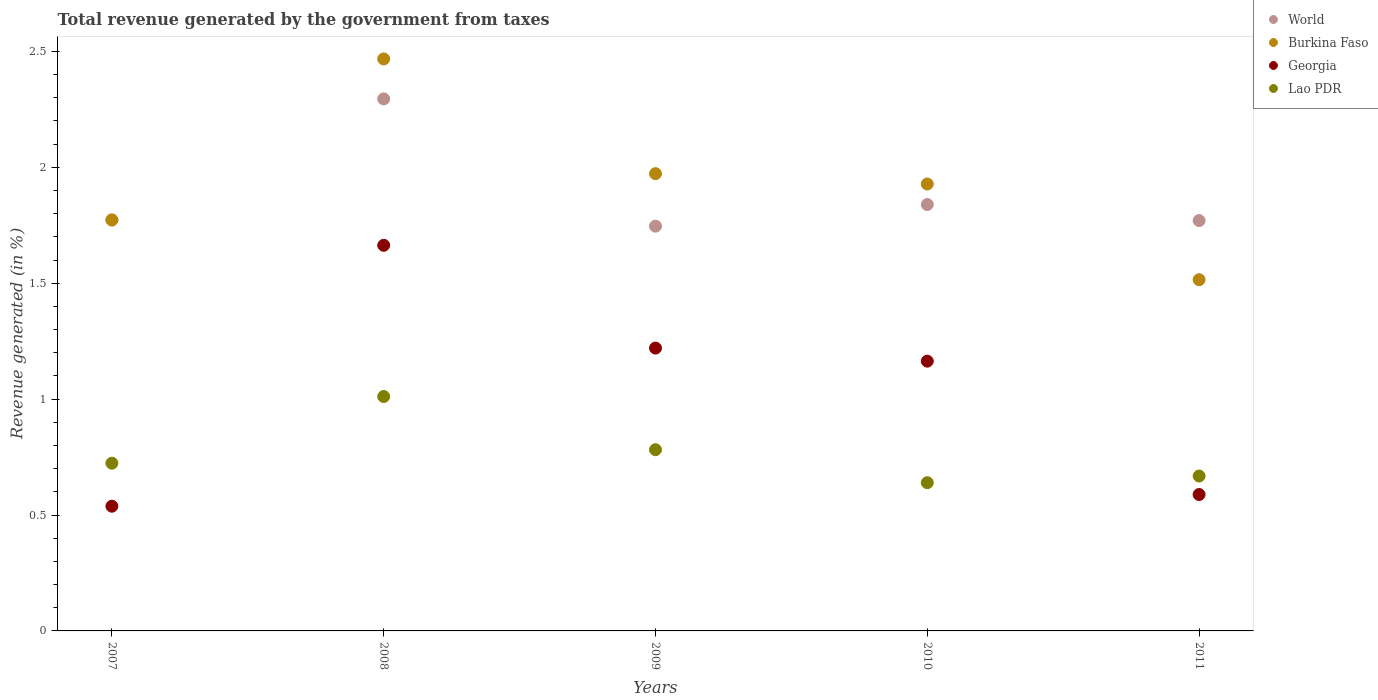How many different coloured dotlines are there?
Keep it short and to the point. 4. What is the total revenue generated in Burkina Faso in 2009?
Your answer should be very brief. 1.97. Across all years, what is the maximum total revenue generated in World?
Your answer should be very brief. 2.3. Across all years, what is the minimum total revenue generated in World?
Provide a short and direct response. 1.75. In which year was the total revenue generated in Lao PDR maximum?
Provide a succinct answer. 2008. What is the total total revenue generated in World in the graph?
Provide a succinct answer. 9.42. What is the difference between the total revenue generated in Georgia in 2008 and that in 2009?
Provide a succinct answer. 0.44. What is the difference between the total revenue generated in World in 2007 and the total revenue generated in Lao PDR in 2010?
Ensure brevity in your answer.  1.13. What is the average total revenue generated in Georgia per year?
Offer a terse response. 1.03. In the year 2011, what is the difference between the total revenue generated in World and total revenue generated in Georgia?
Your response must be concise. 1.18. What is the ratio of the total revenue generated in Burkina Faso in 2007 to that in 2010?
Ensure brevity in your answer.  0.92. Is the difference between the total revenue generated in World in 2009 and 2011 greater than the difference between the total revenue generated in Georgia in 2009 and 2011?
Offer a very short reply. No. What is the difference between the highest and the second highest total revenue generated in World?
Give a very brief answer. 0.46. What is the difference between the highest and the lowest total revenue generated in Georgia?
Make the answer very short. 1.13. Is the sum of the total revenue generated in Lao PDR in 2010 and 2011 greater than the maximum total revenue generated in World across all years?
Ensure brevity in your answer.  No. How many dotlines are there?
Provide a succinct answer. 4. How many years are there in the graph?
Ensure brevity in your answer.  5. Are the values on the major ticks of Y-axis written in scientific E-notation?
Give a very brief answer. No. Does the graph contain any zero values?
Keep it short and to the point. No. Does the graph contain grids?
Provide a short and direct response. No. Where does the legend appear in the graph?
Offer a very short reply. Top right. How many legend labels are there?
Give a very brief answer. 4. How are the legend labels stacked?
Offer a terse response. Vertical. What is the title of the graph?
Your response must be concise. Total revenue generated by the government from taxes. What is the label or title of the Y-axis?
Give a very brief answer. Revenue generated (in %). What is the Revenue generated (in %) in World in 2007?
Your answer should be compact. 1.77. What is the Revenue generated (in %) in Burkina Faso in 2007?
Keep it short and to the point. 1.77. What is the Revenue generated (in %) of Georgia in 2007?
Your answer should be compact. 0.54. What is the Revenue generated (in %) of Lao PDR in 2007?
Your response must be concise. 0.72. What is the Revenue generated (in %) in World in 2008?
Your response must be concise. 2.3. What is the Revenue generated (in %) of Burkina Faso in 2008?
Offer a terse response. 2.47. What is the Revenue generated (in %) in Georgia in 2008?
Give a very brief answer. 1.66. What is the Revenue generated (in %) in Lao PDR in 2008?
Give a very brief answer. 1.01. What is the Revenue generated (in %) in World in 2009?
Offer a very short reply. 1.75. What is the Revenue generated (in %) of Burkina Faso in 2009?
Make the answer very short. 1.97. What is the Revenue generated (in %) in Georgia in 2009?
Provide a short and direct response. 1.22. What is the Revenue generated (in %) of Lao PDR in 2009?
Offer a very short reply. 0.78. What is the Revenue generated (in %) of World in 2010?
Your answer should be compact. 1.84. What is the Revenue generated (in %) of Burkina Faso in 2010?
Provide a short and direct response. 1.93. What is the Revenue generated (in %) in Georgia in 2010?
Provide a succinct answer. 1.16. What is the Revenue generated (in %) of Lao PDR in 2010?
Your response must be concise. 0.64. What is the Revenue generated (in %) of World in 2011?
Ensure brevity in your answer.  1.77. What is the Revenue generated (in %) in Burkina Faso in 2011?
Provide a short and direct response. 1.52. What is the Revenue generated (in %) of Georgia in 2011?
Your answer should be compact. 0.59. What is the Revenue generated (in %) in Lao PDR in 2011?
Your response must be concise. 0.67. Across all years, what is the maximum Revenue generated (in %) of World?
Provide a succinct answer. 2.3. Across all years, what is the maximum Revenue generated (in %) of Burkina Faso?
Your response must be concise. 2.47. Across all years, what is the maximum Revenue generated (in %) in Georgia?
Your answer should be very brief. 1.66. Across all years, what is the maximum Revenue generated (in %) of Lao PDR?
Give a very brief answer. 1.01. Across all years, what is the minimum Revenue generated (in %) of World?
Your answer should be compact. 1.75. Across all years, what is the minimum Revenue generated (in %) of Burkina Faso?
Keep it short and to the point. 1.52. Across all years, what is the minimum Revenue generated (in %) of Georgia?
Your response must be concise. 0.54. Across all years, what is the minimum Revenue generated (in %) in Lao PDR?
Your response must be concise. 0.64. What is the total Revenue generated (in %) in World in the graph?
Offer a very short reply. 9.42. What is the total Revenue generated (in %) of Burkina Faso in the graph?
Offer a very short reply. 9.66. What is the total Revenue generated (in %) in Georgia in the graph?
Provide a succinct answer. 5.17. What is the total Revenue generated (in %) in Lao PDR in the graph?
Your response must be concise. 3.82. What is the difference between the Revenue generated (in %) in World in 2007 and that in 2008?
Your response must be concise. -0.52. What is the difference between the Revenue generated (in %) in Burkina Faso in 2007 and that in 2008?
Offer a very short reply. -0.69. What is the difference between the Revenue generated (in %) of Georgia in 2007 and that in 2008?
Your answer should be compact. -1.13. What is the difference between the Revenue generated (in %) in Lao PDR in 2007 and that in 2008?
Give a very brief answer. -0.29. What is the difference between the Revenue generated (in %) in World in 2007 and that in 2009?
Give a very brief answer. 0.03. What is the difference between the Revenue generated (in %) in Burkina Faso in 2007 and that in 2009?
Make the answer very short. -0.2. What is the difference between the Revenue generated (in %) in Georgia in 2007 and that in 2009?
Keep it short and to the point. -0.68. What is the difference between the Revenue generated (in %) in Lao PDR in 2007 and that in 2009?
Your answer should be very brief. -0.06. What is the difference between the Revenue generated (in %) of World in 2007 and that in 2010?
Ensure brevity in your answer.  -0.07. What is the difference between the Revenue generated (in %) of Burkina Faso in 2007 and that in 2010?
Provide a succinct answer. -0.16. What is the difference between the Revenue generated (in %) of Georgia in 2007 and that in 2010?
Provide a succinct answer. -0.63. What is the difference between the Revenue generated (in %) in Lao PDR in 2007 and that in 2010?
Make the answer very short. 0.08. What is the difference between the Revenue generated (in %) of World in 2007 and that in 2011?
Your answer should be compact. 0. What is the difference between the Revenue generated (in %) in Burkina Faso in 2007 and that in 2011?
Provide a succinct answer. 0.26. What is the difference between the Revenue generated (in %) in Georgia in 2007 and that in 2011?
Offer a terse response. -0.05. What is the difference between the Revenue generated (in %) in Lao PDR in 2007 and that in 2011?
Make the answer very short. 0.06. What is the difference between the Revenue generated (in %) in World in 2008 and that in 2009?
Give a very brief answer. 0.55. What is the difference between the Revenue generated (in %) in Burkina Faso in 2008 and that in 2009?
Provide a succinct answer. 0.49. What is the difference between the Revenue generated (in %) of Georgia in 2008 and that in 2009?
Provide a succinct answer. 0.44. What is the difference between the Revenue generated (in %) of Lao PDR in 2008 and that in 2009?
Provide a succinct answer. 0.23. What is the difference between the Revenue generated (in %) of World in 2008 and that in 2010?
Provide a short and direct response. 0.46. What is the difference between the Revenue generated (in %) of Burkina Faso in 2008 and that in 2010?
Provide a short and direct response. 0.54. What is the difference between the Revenue generated (in %) of Georgia in 2008 and that in 2010?
Offer a terse response. 0.5. What is the difference between the Revenue generated (in %) in Lao PDR in 2008 and that in 2010?
Provide a succinct answer. 0.37. What is the difference between the Revenue generated (in %) of World in 2008 and that in 2011?
Ensure brevity in your answer.  0.52. What is the difference between the Revenue generated (in %) of Georgia in 2008 and that in 2011?
Your answer should be very brief. 1.08. What is the difference between the Revenue generated (in %) in Lao PDR in 2008 and that in 2011?
Give a very brief answer. 0.34. What is the difference between the Revenue generated (in %) in World in 2009 and that in 2010?
Provide a short and direct response. -0.09. What is the difference between the Revenue generated (in %) of Burkina Faso in 2009 and that in 2010?
Give a very brief answer. 0.04. What is the difference between the Revenue generated (in %) of Georgia in 2009 and that in 2010?
Your answer should be very brief. 0.06. What is the difference between the Revenue generated (in %) in Lao PDR in 2009 and that in 2010?
Provide a short and direct response. 0.14. What is the difference between the Revenue generated (in %) of World in 2009 and that in 2011?
Keep it short and to the point. -0.02. What is the difference between the Revenue generated (in %) in Burkina Faso in 2009 and that in 2011?
Make the answer very short. 0.46. What is the difference between the Revenue generated (in %) of Georgia in 2009 and that in 2011?
Make the answer very short. 0.63. What is the difference between the Revenue generated (in %) in Lao PDR in 2009 and that in 2011?
Provide a succinct answer. 0.11. What is the difference between the Revenue generated (in %) of World in 2010 and that in 2011?
Give a very brief answer. 0.07. What is the difference between the Revenue generated (in %) of Burkina Faso in 2010 and that in 2011?
Provide a succinct answer. 0.41. What is the difference between the Revenue generated (in %) in Georgia in 2010 and that in 2011?
Offer a terse response. 0.58. What is the difference between the Revenue generated (in %) in Lao PDR in 2010 and that in 2011?
Provide a succinct answer. -0.03. What is the difference between the Revenue generated (in %) in World in 2007 and the Revenue generated (in %) in Burkina Faso in 2008?
Offer a very short reply. -0.69. What is the difference between the Revenue generated (in %) of World in 2007 and the Revenue generated (in %) of Georgia in 2008?
Make the answer very short. 0.11. What is the difference between the Revenue generated (in %) in World in 2007 and the Revenue generated (in %) in Lao PDR in 2008?
Your response must be concise. 0.76. What is the difference between the Revenue generated (in %) in Burkina Faso in 2007 and the Revenue generated (in %) in Georgia in 2008?
Provide a short and direct response. 0.11. What is the difference between the Revenue generated (in %) in Burkina Faso in 2007 and the Revenue generated (in %) in Lao PDR in 2008?
Give a very brief answer. 0.76. What is the difference between the Revenue generated (in %) of Georgia in 2007 and the Revenue generated (in %) of Lao PDR in 2008?
Provide a short and direct response. -0.47. What is the difference between the Revenue generated (in %) of World in 2007 and the Revenue generated (in %) of Burkina Faso in 2009?
Give a very brief answer. -0.2. What is the difference between the Revenue generated (in %) of World in 2007 and the Revenue generated (in %) of Georgia in 2009?
Your answer should be very brief. 0.55. What is the difference between the Revenue generated (in %) in World in 2007 and the Revenue generated (in %) in Lao PDR in 2009?
Offer a very short reply. 0.99. What is the difference between the Revenue generated (in %) in Burkina Faso in 2007 and the Revenue generated (in %) in Georgia in 2009?
Provide a short and direct response. 0.55. What is the difference between the Revenue generated (in %) of Burkina Faso in 2007 and the Revenue generated (in %) of Lao PDR in 2009?
Ensure brevity in your answer.  0.99. What is the difference between the Revenue generated (in %) of Georgia in 2007 and the Revenue generated (in %) of Lao PDR in 2009?
Make the answer very short. -0.24. What is the difference between the Revenue generated (in %) of World in 2007 and the Revenue generated (in %) of Burkina Faso in 2010?
Give a very brief answer. -0.16. What is the difference between the Revenue generated (in %) in World in 2007 and the Revenue generated (in %) in Georgia in 2010?
Make the answer very short. 0.61. What is the difference between the Revenue generated (in %) in World in 2007 and the Revenue generated (in %) in Lao PDR in 2010?
Ensure brevity in your answer.  1.13. What is the difference between the Revenue generated (in %) in Burkina Faso in 2007 and the Revenue generated (in %) in Georgia in 2010?
Provide a short and direct response. 0.61. What is the difference between the Revenue generated (in %) in Burkina Faso in 2007 and the Revenue generated (in %) in Lao PDR in 2010?
Make the answer very short. 1.13. What is the difference between the Revenue generated (in %) in Georgia in 2007 and the Revenue generated (in %) in Lao PDR in 2010?
Give a very brief answer. -0.1. What is the difference between the Revenue generated (in %) of World in 2007 and the Revenue generated (in %) of Burkina Faso in 2011?
Make the answer very short. 0.26. What is the difference between the Revenue generated (in %) in World in 2007 and the Revenue generated (in %) in Georgia in 2011?
Your answer should be compact. 1.18. What is the difference between the Revenue generated (in %) in World in 2007 and the Revenue generated (in %) in Lao PDR in 2011?
Keep it short and to the point. 1.1. What is the difference between the Revenue generated (in %) of Burkina Faso in 2007 and the Revenue generated (in %) of Georgia in 2011?
Offer a terse response. 1.18. What is the difference between the Revenue generated (in %) of Burkina Faso in 2007 and the Revenue generated (in %) of Lao PDR in 2011?
Make the answer very short. 1.1. What is the difference between the Revenue generated (in %) in Georgia in 2007 and the Revenue generated (in %) in Lao PDR in 2011?
Ensure brevity in your answer.  -0.13. What is the difference between the Revenue generated (in %) in World in 2008 and the Revenue generated (in %) in Burkina Faso in 2009?
Keep it short and to the point. 0.32. What is the difference between the Revenue generated (in %) in World in 2008 and the Revenue generated (in %) in Georgia in 2009?
Give a very brief answer. 1.08. What is the difference between the Revenue generated (in %) of World in 2008 and the Revenue generated (in %) of Lao PDR in 2009?
Provide a short and direct response. 1.51. What is the difference between the Revenue generated (in %) of Burkina Faso in 2008 and the Revenue generated (in %) of Georgia in 2009?
Offer a very short reply. 1.25. What is the difference between the Revenue generated (in %) of Burkina Faso in 2008 and the Revenue generated (in %) of Lao PDR in 2009?
Offer a terse response. 1.69. What is the difference between the Revenue generated (in %) of Georgia in 2008 and the Revenue generated (in %) of Lao PDR in 2009?
Offer a terse response. 0.88. What is the difference between the Revenue generated (in %) of World in 2008 and the Revenue generated (in %) of Burkina Faso in 2010?
Ensure brevity in your answer.  0.37. What is the difference between the Revenue generated (in %) in World in 2008 and the Revenue generated (in %) in Georgia in 2010?
Make the answer very short. 1.13. What is the difference between the Revenue generated (in %) in World in 2008 and the Revenue generated (in %) in Lao PDR in 2010?
Offer a very short reply. 1.66. What is the difference between the Revenue generated (in %) in Burkina Faso in 2008 and the Revenue generated (in %) in Georgia in 2010?
Your answer should be compact. 1.3. What is the difference between the Revenue generated (in %) of Burkina Faso in 2008 and the Revenue generated (in %) of Lao PDR in 2010?
Offer a terse response. 1.83. What is the difference between the Revenue generated (in %) of Georgia in 2008 and the Revenue generated (in %) of Lao PDR in 2010?
Your response must be concise. 1.02. What is the difference between the Revenue generated (in %) in World in 2008 and the Revenue generated (in %) in Burkina Faso in 2011?
Ensure brevity in your answer.  0.78. What is the difference between the Revenue generated (in %) in World in 2008 and the Revenue generated (in %) in Georgia in 2011?
Provide a short and direct response. 1.71. What is the difference between the Revenue generated (in %) in World in 2008 and the Revenue generated (in %) in Lao PDR in 2011?
Give a very brief answer. 1.63. What is the difference between the Revenue generated (in %) in Burkina Faso in 2008 and the Revenue generated (in %) in Georgia in 2011?
Your response must be concise. 1.88. What is the difference between the Revenue generated (in %) of Burkina Faso in 2008 and the Revenue generated (in %) of Lao PDR in 2011?
Provide a succinct answer. 1.8. What is the difference between the Revenue generated (in %) of Georgia in 2008 and the Revenue generated (in %) of Lao PDR in 2011?
Keep it short and to the point. 1. What is the difference between the Revenue generated (in %) of World in 2009 and the Revenue generated (in %) of Burkina Faso in 2010?
Offer a very short reply. -0.18. What is the difference between the Revenue generated (in %) in World in 2009 and the Revenue generated (in %) in Georgia in 2010?
Your answer should be compact. 0.58. What is the difference between the Revenue generated (in %) of World in 2009 and the Revenue generated (in %) of Lao PDR in 2010?
Offer a terse response. 1.11. What is the difference between the Revenue generated (in %) in Burkina Faso in 2009 and the Revenue generated (in %) in Georgia in 2010?
Make the answer very short. 0.81. What is the difference between the Revenue generated (in %) in Burkina Faso in 2009 and the Revenue generated (in %) in Lao PDR in 2010?
Offer a very short reply. 1.33. What is the difference between the Revenue generated (in %) of Georgia in 2009 and the Revenue generated (in %) of Lao PDR in 2010?
Provide a short and direct response. 0.58. What is the difference between the Revenue generated (in %) of World in 2009 and the Revenue generated (in %) of Burkina Faso in 2011?
Your answer should be compact. 0.23. What is the difference between the Revenue generated (in %) of World in 2009 and the Revenue generated (in %) of Georgia in 2011?
Your answer should be very brief. 1.16. What is the difference between the Revenue generated (in %) of World in 2009 and the Revenue generated (in %) of Lao PDR in 2011?
Your response must be concise. 1.08. What is the difference between the Revenue generated (in %) of Burkina Faso in 2009 and the Revenue generated (in %) of Georgia in 2011?
Offer a terse response. 1.38. What is the difference between the Revenue generated (in %) of Burkina Faso in 2009 and the Revenue generated (in %) of Lao PDR in 2011?
Your answer should be very brief. 1.3. What is the difference between the Revenue generated (in %) in Georgia in 2009 and the Revenue generated (in %) in Lao PDR in 2011?
Offer a very short reply. 0.55. What is the difference between the Revenue generated (in %) in World in 2010 and the Revenue generated (in %) in Burkina Faso in 2011?
Keep it short and to the point. 0.32. What is the difference between the Revenue generated (in %) of World in 2010 and the Revenue generated (in %) of Georgia in 2011?
Ensure brevity in your answer.  1.25. What is the difference between the Revenue generated (in %) in World in 2010 and the Revenue generated (in %) in Lao PDR in 2011?
Offer a very short reply. 1.17. What is the difference between the Revenue generated (in %) of Burkina Faso in 2010 and the Revenue generated (in %) of Georgia in 2011?
Offer a very short reply. 1.34. What is the difference between the Revenue generated (in %) of Burkina Faso in 2010 and the Revenue generated (in %) of Lao PDR in 2011?
Keep it short and to the point. 1.26. What is the difference between the Revenue generated (in %) in Georgia in 2010 and the Revenue generated (in %) in Lao PDR in 2011?
Give a very brief answer. 0.5. What is the average Revenue generated (in %) in World per year?
Provide a succinct answer. 1.89. What is the average Revenue generated (in %) in Burkina Faso per year?
Offer a terse response. 1.93. What is the average Revenue generated (in %) of Georgia per year?
Provide a short and direct response. 1.03. What is the average Revenue generated (in %) in Lao PDR per year?
Your answer should be compact. 0.76. In the year 2007, what is the difference between the Revenue generated (in %) in World and Revenue generated (in %) in Burkina Faso?
Provide a succinct answer. 0. In the year 2007, what is the difference between the Revenue generated (in %) of World and Revenue generated (in %) of Georgia?
Your response must be concise. 1.24. In the year 2007, what is the difference between the Revenue generated (in %) in World and Revenue generated (in %) in Lao PDR?
Keep it short and to the point. 1.05. In the year 2007, what is the difference between the Revenue generated (in %) of Burkina Faso and Revenue generated (in %) of Georgia?
Your answer should be very brief. 1.24. In the year 2007, what is the difference between the Revenue generated (in %) in Burkina Faso and Revenue generated (in %) in Lao PDR?
Your answer should be compact. 1.05. In the year 2007, what is the difference between the Revenue generated (in %) in Georgia and Revenue generated (in %) in Lao PDR?
Your answer should be compact. -0.19. In the year 2008, what is the difference between the Revenue generated (in %) in World and Revenue generated (in %) in Burkina Faso?
Your answer should be very brief. -0.17. In the year 2008, what is the difference between the Revenue generated (in %) of World and Revenue generated (in %) of Georgia?
Give a very brief answer. 0.63. In the year 2008, what is the difference between the Revenue generated (in %) in World and Revenue generated (in %) in Lao PDR?
Ensure brevity in your answer.  1.28. In the year 2008, what is the difference between the Revenue generated (in %) in Burkina Faso and Revenue generated (in %) in Georgia?
Your response must be concise. 0.8. In the year 2008, what is the difference between the Revenue generated (in %) in Burkina Faso and Revenue generated (in %) in Lao PDR?
Offer a very short reply. 1.46. In the year 2008, what is the difference between the Revenue generated (in %) in Georgia and Revenue generated (in %) in Lao PDR?
Offer a very short reply. 0.65. In the year 2009, what is the difference between the Revenue generated (in %) in World and Revenue generated (in %) in Burkina Faso?
Offer a terse response. -0.23. In the year 2009, what is the difference between the Revenue generated (in %) of World and Revenue generated (in %) of Georgia?
Keep it short and to the point. 0.53. In the year 2009, what is the difference between the Revenue generated (in %) in World and Revenue generated (in %) in Lao PDR?
Provide a succinct answer. 0.96. In the year 2009, what is the difference between the Revenue generated (in %) of Burkina Faso and Revenue generated (in %) of Georgia?
Offer a terse response. 0.75. In the year 2009, what is the difference between the Revenue generated (in %) of Burkina Faso and Revenue generated (in %) of Lao PDR?
Ensure brevity in your answer.  1.19. In the year 2009, what is the difference between the Revenue generated (in %) of Georgia and Revenue generated (in %) of Lao PDR?
Your response must be concise. 0.44. In the year 2010, what is the difference between the Revenue generated (in %) in World and Revenue generated (in %) in Burkina Faso?
Give a very brief answer. -0.09. In the year 2010, what is the difference between the Revenue generated (in %) of World and Revenue generated (in %) of Georgia?
Make the answer very short. 0.68. In the year 2010, what is the difference between the Revenue generated (in %) of World and Revenue generated (in %) of Lao PDR?
Offer a very short reply. 1.2. In the year 2010, what is the difference between the Revenue generated (in %) of Burkina Faso and Revenue generated (in %) of Georgia?
Make the answer very short. 0.76. In the year 2010, what is the difference between the Revenue generated (in %) of Burkina Faso and Revenue generated (in %) of Lao PDR?
Your response must be concise. 1.29. In the year 2010, what is the difference between the Revenue generated (in %) in Georgia and Revenue generated (in %) in Lao PDR?
Keep it short and to the point. 0.52. In the year 2011, what is the difference between the Revenue generated (in %) in World and Revenue generated (in %) in Burkina Faso?
Offer a very short reply. 0.26. In the year 2011, what is the difference between the Revenue generated (in %) of World and Revenue generated (in %) of Georgia?
Provide a short and direct response. 1.18. In the year 2011, what is the difference between the Revenue generated (in %) in World and Revenue generated (in %) in Lao PDR?
Your answer should be very brief. 1.1. In the year 2011, what is the difference between the Revenue generated (in %) in Burkina Faso and Revenue generated (in %) in Georgia?
Offer a very short reply. 0.93. In the year 2011, what is the difference between the Revenue generated (in %) of Burkina Faso and Revenue generated (in %) of Lao PDR?
Give a very brief answer. 0.85. In the year 2011, what is the difference between the Revenue generated (in %) of Georgia and Revenue generated (in %) of Lao PDR?
Your answer should be compact. -0.08. What is the ratio of the Revenue generated (in %) in World in 2007 to that in 2008?
Your answer should be very brief. 0.77. What is the ratio of the Revenue generated (in %) in Burkina Faso in 2007 to that in 2008?
Make the answer very short. 0.72. What is the ratio of the Revenue generated (in %) in Georgia in 2007 to that in 2008?
Give a very brief answer. 0.32. What is the ratio of the Revenue generated (in %) in Lao PDR in 2007 to that in 2008?
Provide a short and direct response. 0.72. What is the ratio of the Revenue generated (in %) of World in 2007 to that in 2009?
Ensure brevity in your answer.  1.02. What is the ratio of the Revenue generated (in %) of Burkina Faso in 2007 to that in 2009?
Your answer should be compact. 0.9. What is the ratio of the Revenue generated (in %) in Georgia in 2007 to that in 2009?
Provide a short and direct response. 0.44. What is the ratio of the Revenue generated (in %) in Lao PDR in 2007 to that in 2009?
Provide a succinct answer. 0.93. What is the ratio of the Revenue generated (in %) in World in 2007 to that in 2010?
Offer a terse response. 0.96. What is the ratio of the Revenue generated (in %) of Burkina Faso in 2007 to that in 2010?
Provide a short and direct response. 0.92. What is the ratio of the Revenue generated (in %) of Georgia in 2007 to that in 2010?
Keep it short and to the point. 0.46. What is the ratio of the Revenue generated (in %) in Lao PDR in 2007 to that in 2010?
Provide a short and direct response. 1.13. What is the ratio of the Revenue generated (in %) of Burkina Faso in 2007 to that in 2011?
Offer a very short reply. 1.17. What is the ratio of the Revenue generated (in %) of Georgia in 2007 to that in 2011?
Make the answer very short. 0.91. What is the ratio of the Revenue generated (in %) of Lao PDR in 2007 to that in 2011?
Keep it short and to the point. 1.08. What is the ratio of the Revenue generated (in %) of World in 2008 to that in 2009?
Your answer should be very brief. 1.31. What is the ratio of the Revenue generated (in %) of Burkina Faso in 2008 to that in 2009?
Give a very brief answer. 1.25. What is the ratio of the Revenue generated (in %) in Georgia in 2008 to that in 2009?
Offer a very short reply. 1.36. What is the ratio of the Revenue generated (in %) in Lao PDR in 2008 to that in 2009?
Your answer should be very brief. 1.29. What is the ratio of the Revenue generated (in %) in World in 2008 to that in 2010?
Your answer should be compact. 1.25. What is the ratio of the Revenue generated (in %) of Burkina Faso in 2008 to that in 2010?
Provide a short and direct response. 1.28. What is the ratio of the Revenue generated (in %) of Georgia in 2008 to that in 2010?
Keep it short and to the point. 1.43. What is the ratio of the Revenue generated (in %) of Lao PDR in 2008 to that in 2010?
Offer a terse response. 1.58. What is the ratio of the Revenue generated (in %) in World in 2008 to that in 2011?
Offer a terse response. 1.3. What is the ratio of the Revenue generated (in %) in Burkina Faso in 2008 to that in 2011?
Your answer should be compact. 1.63. What is the ratio of the Revenue generated (in %) in Georgia in 2008 to that in 2011?
Make the answer very short. 2.83. What is the ratio of the Revenue generated (in %) of Lao PDR in 2008 to that in 2011?
Your response must be concise. 1.51. What is the ratio of the Revenue generated (in %) of World in 2009 to that in 2010?
Ensure brevity in your answer.  0.95. What is the ratio of the Revenue generated (in %) of Burkina Faso in 2009 to that in 2010?
Offer a terse response. 1.02. What is the ratio of the Revenue generated (in %) in Georgia in 2009 to that in 2010?
Your answer should be very brief. 1.05. What is the ratio of the Revenue generated (in %) of Lao PDR in 2009 to that in 2010?
Ensure brevity in your answer.  1.22. What is the ratio of the Revenue generated (in %) of World in 2009 to that in 2011?
Provide a short and direct response. 0.99. What is the ratio of the Revenue generated (in %) of Burkina Faso in 2009 to that in 2011?
Make the answer very short. 1.3. What is the ratio of the Revenue generated (in %) of Georgia in 2009 to that in 2011?
Provide a succinct answer. 2.07. What is the ratio of the Revenue generated (in %) in Lao PDR in 2009 to that in 2011?
Offer a very short reply. 1.17. What is the ratio of the Revenue generated (in %) in World in 2010 to that in 2011?
Your response must be concise. 1.04. What is the ratio of the Revenue generated (in %) of Burkina Faso in 2010 to that in 2011?
Ensure brevity in your answer.  1.27. What is the ratio of the Revenue generated (in %) in Georgia in 2010 to that in 2011?
Your answer should be compact. 1.98. What is the ratio of the Revenue generated (in %) of Lao PDR in 2010 to that in 2011?
Offer a terse response. 0.96. What is the difference between the highest and the second highest Revenue generated (in %) of World?
Your answer should be compact. 0.46. What is the difference between the highest and the second highest Revenue generated (in %) in Burkina Faso?
Give a very brief answer. 0.49. What is the difference between the highest and the second highest Revenue generated (in %) in Georgia?
Your response must be concise. 0.44. What is the difference between the highest and the second highest Revenue generated (in %) in Lao PDR?
Give a very brief answer. 0.23. What is the difference between the highest and the lowest Revenue generated (in %) of World?
Ensure brevity in your answer.  0.55. What is the difference between the highest and the lowest Revenue generated (in %) in Georgia?
Make the answer very short. 1.13. What is the difference between the highest and the lowest Revenue generated (in %) in Lao PDR?
Keep it short and to the point. 0.37. 